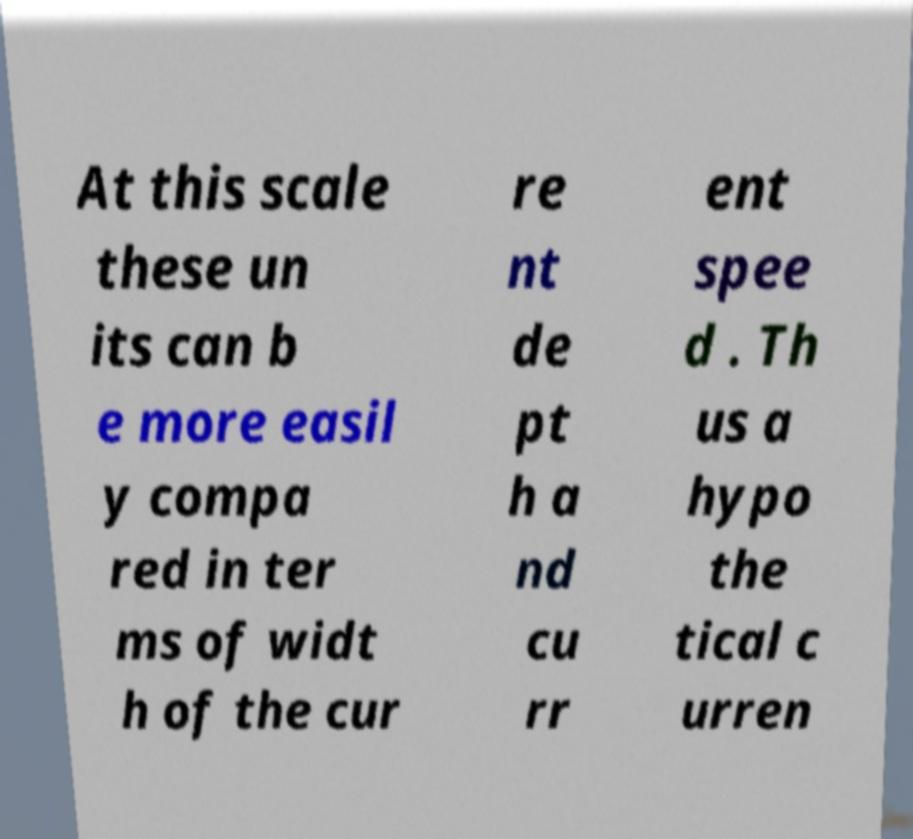There's text embedded in this image that I need extracted. Can you transcribe it verbatim? At this scale these un its can b e more easil y compa red in ter ms of widt h of the cur re nt de pt h a nd cu rr ent spee d . Th us a hypo the tical c urren 